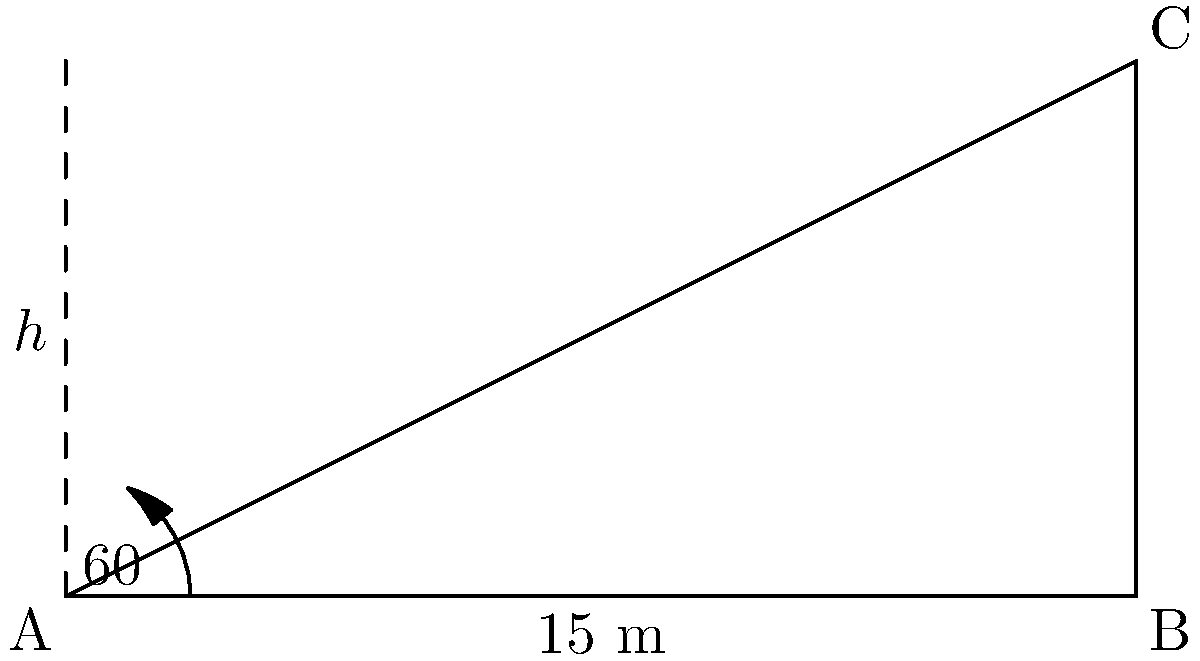During a conservation field trip, you want to demonstrate to students how to measure the height of a tree without climbing it. You notice that the tree casts a shadow 15 meters long when the angle of elevation of the sun is 60°. Using this information, calculate the height of the tree to the nearest meter. Let's approach this step-by-step:

1) We can use the tangent function to solve this problem. The tangent of an angle in a right triangle is the ratio of the opposite side to the adjacent side.

2) In this case:
   - The angle of elevation is 60°
   - The adjacent side (shadow length) is 15 meters
   - The opposite side (tree height) is what we're trying to find

3) Let's call the tree height $h$. We can write the equation:

   $$\tan(60°) = \frac{h}{15}$$

4) We know that $\tan(60°) = \sqrt{3}$, so we can rewrite the equation:

   $$\sqrt{3} = \frac{h}{15}$$

5) To solve for $h$, multiply both sides by 15:

   $$15\sqrt{3} = h$$

6) Now, let's calculate this:
   
   $$h = 15 * \sqrt{3} \approx 15 * 1.732 \approx 25.98$$

7) Rounding to the nearest meter:

   $$h \approx 26\text{ meters}$$
Answer: 26 meters 